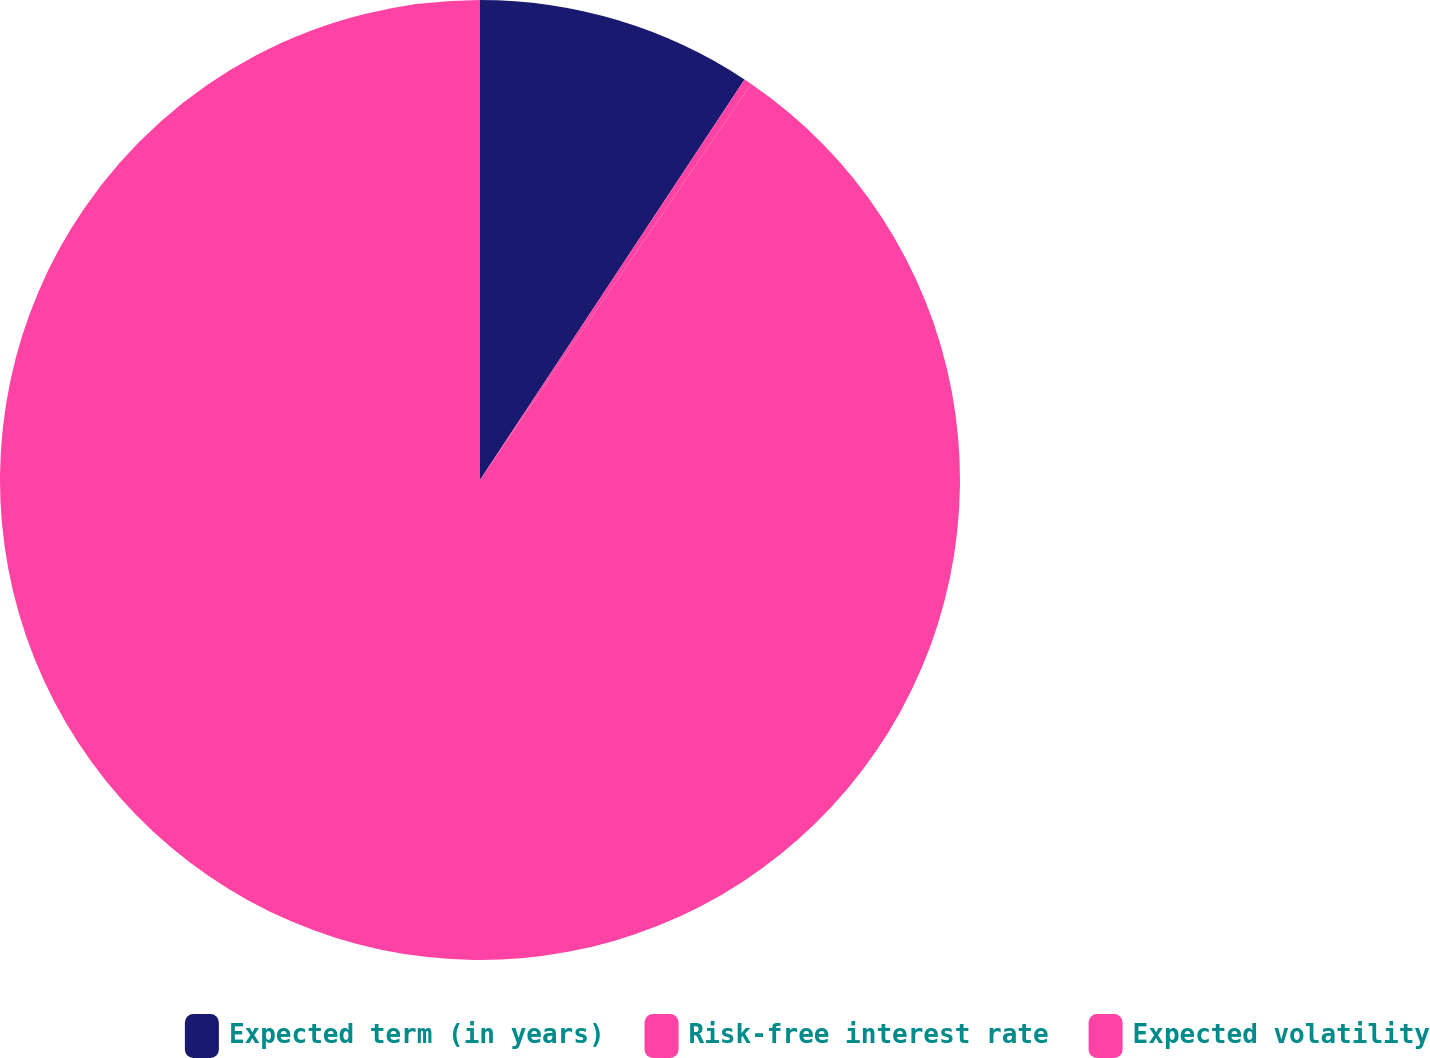<chart> <loc_0><loc_0><loc_500><loc_500><pie_chart><fcel>Expected term (in years)<fcel>Risk-free interest rate<fcel>Expected volatility<nl><fcel>9.29%<fcel>0.27%<fcel>90.44%<nl></chart> 